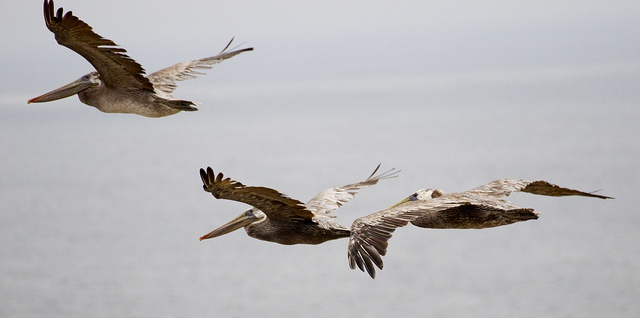Describe the objects in this image and their specific colors. I can see bird in lightgray, black, darkgray, and maroon tones, bird in lightgray, black, maroon, and darkgray tones, and bird in lightgray, black, and maroon tones in this image. 